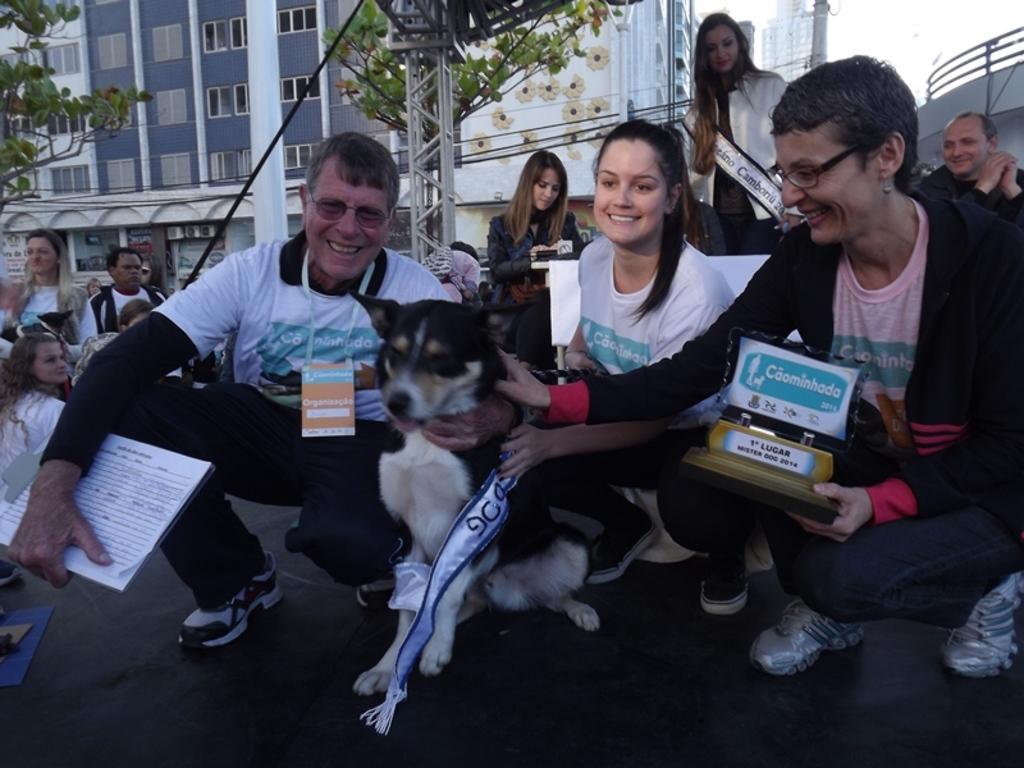Please provide a concise description of this image. An outdoor picture. This person is holding a dog and book. This person is holding a shield. This is a building with windows. This is a pole. This is tree. This person is standing. 